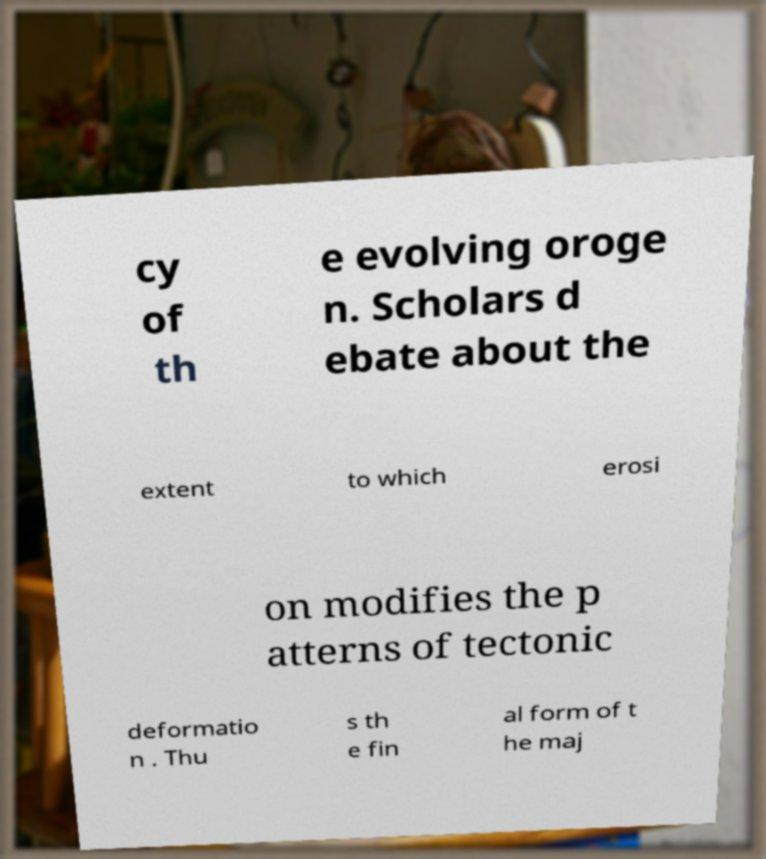What messages or text are displayed in this image? I need them in a readable, typed format. cy of th e evolving oroge n. Scholars d ebate about the extent to which erosi on modifies the p atterns of tectonic deformatio n . Thu s th e fin al form of t he maj 